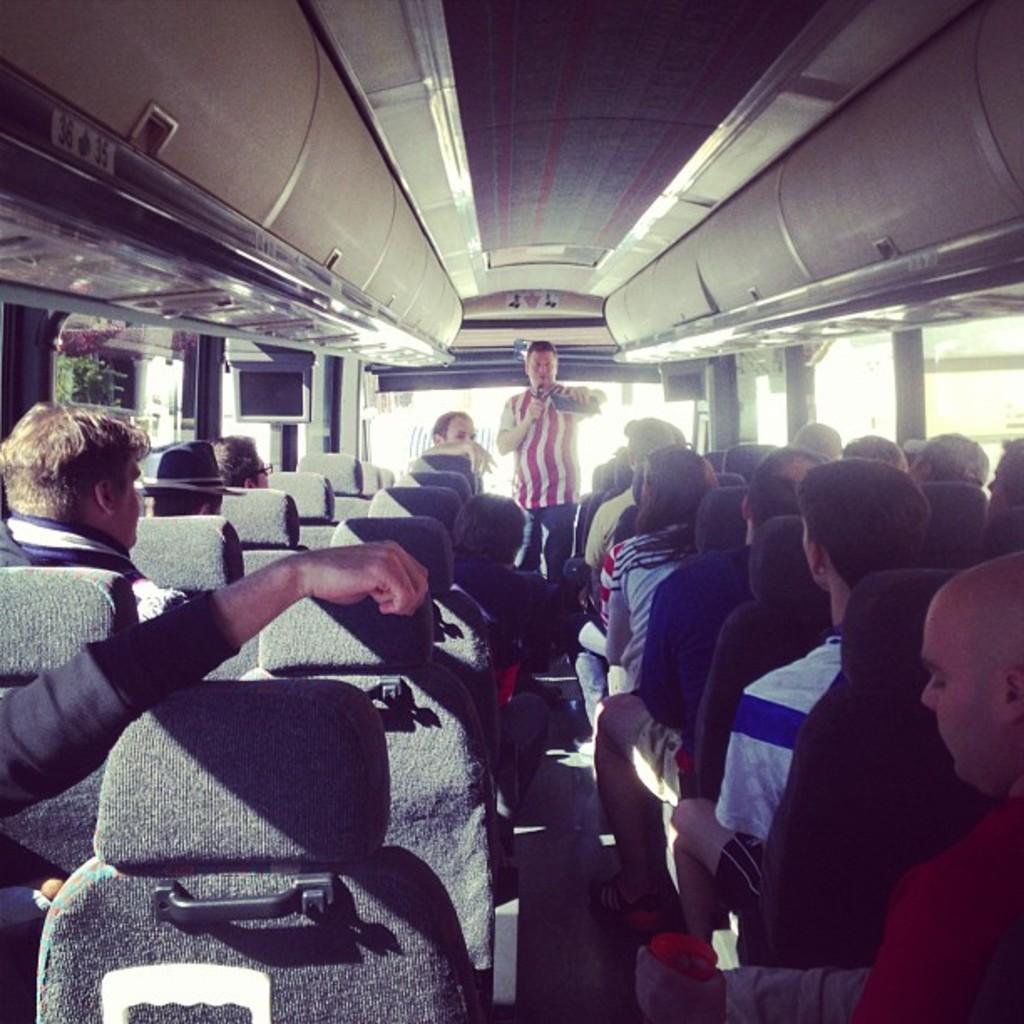How would you summarize this image in a sentence or two? In this image I can see the interior of the vehicle and I can see number of persons are sitting in chairs which are black in color and in the background I can see a person wearing red and white colored dress is standing and holding a microphone. I can see few windows through which I can see few trees and a building. 